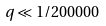Convert formula to latex. <formula><loc_0><loc_0><loc_500><loc_500>q \ll 1 / 2 0 0 0 0 0</formula> 